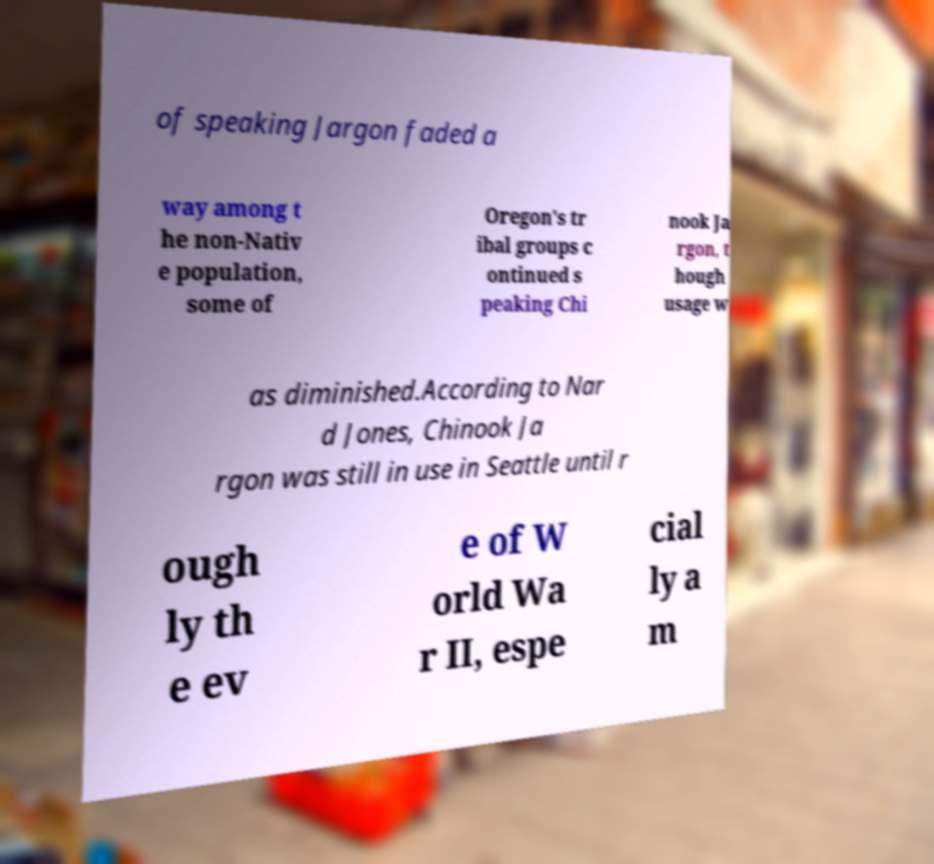There's text embedded in this image that I need extracted. Can you transcribe it verbatim? of speaking Jargon faded a way among t he non-Nativ e population, some of Oregon's tr ibal groups c ontinued s peaking Chi nook Ja rgon, t hough usage w as diminished.According to Nar d Jones, Chinook Ja rgon was still in use in Seattle until r ough ly th e ev e of W orld Wa r II, espe cial ly a m 